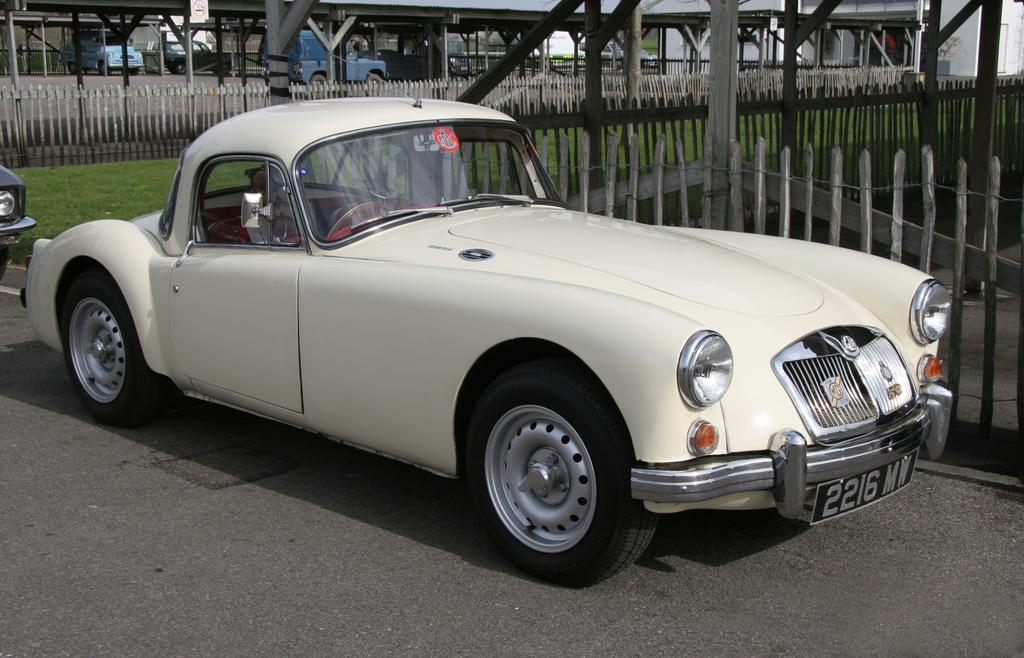What type of vehicle is in the image? There is a white car in the image. Where is the car located? The car is parked on the road. What can be seen in the background of the image? There is fencing, poles, grass, other vehicles, and a wall in the background of the image. How does the car burn fuel while parked in the image? The car does not burn fuel while parked in the image; it is stationary and not consuming any fuel. 